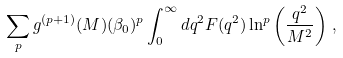<formula> <loc_0><loc_0><loc_500><loc_500>\sum _ { p } g ^ { ( p + 1 ) } ( M ) ( \beta _ { 0 } ) ^ { p } \int _ { 0 } ^ { \infty } d q ^ { 2 } F ( q ^ { 2 } ) \ln ^ { p } \left ( \frac { q ^ { 2 } } { M ^ { 2 } } \right ) \, ,</formula> 